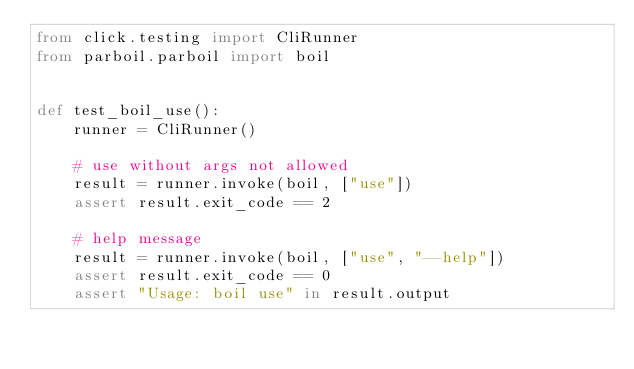Convert code to text. <code><loc_0><loc_0><loc_500><loc_500><_Python_>from click.testing import CliRunner
from parboil.parboil import boil


def test_boil_use():
    runner = CliRunner()

    # use without args not allowed
    result = runner.invoke(boil, ["use"])
    assert result.exit_code == 2

    # help message
    result = runner.invoke(boil, ["use", "--help"])
    assert result.exit_code == 0
    assert "Usage: boil use" in result.output
</code> 